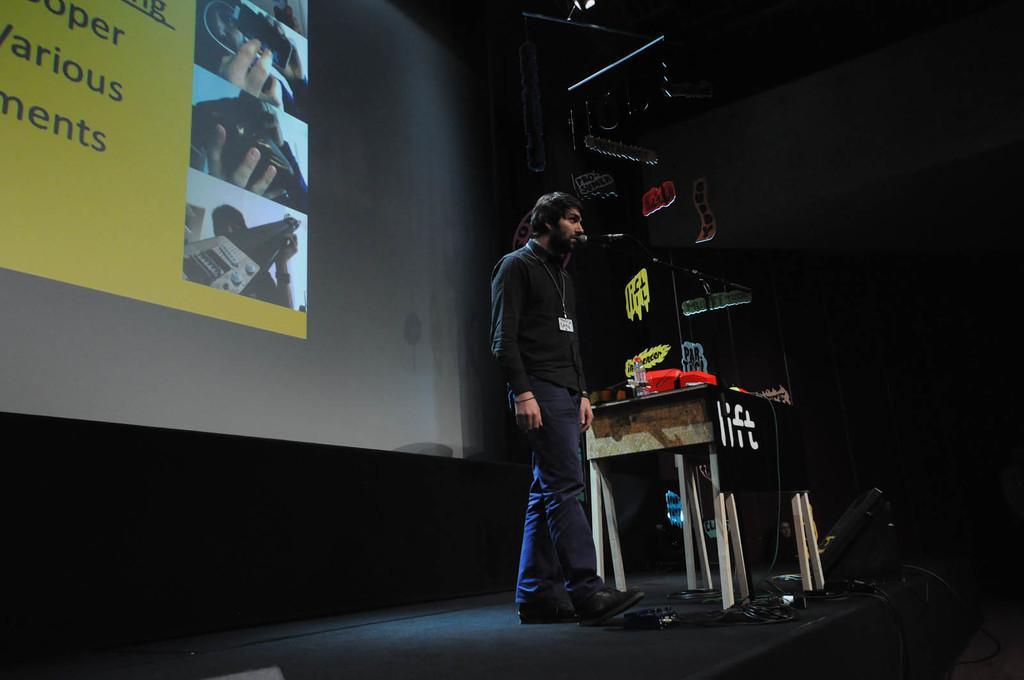In one or two sentences, can you explain what this image depicts? In this picture we can see a man, he is standing, in front of him we can see a microphone, and we can find a bottle and few other things on the table, in the background we can see a projector screen, beside to him we can see few cables, speaker and few other things. 